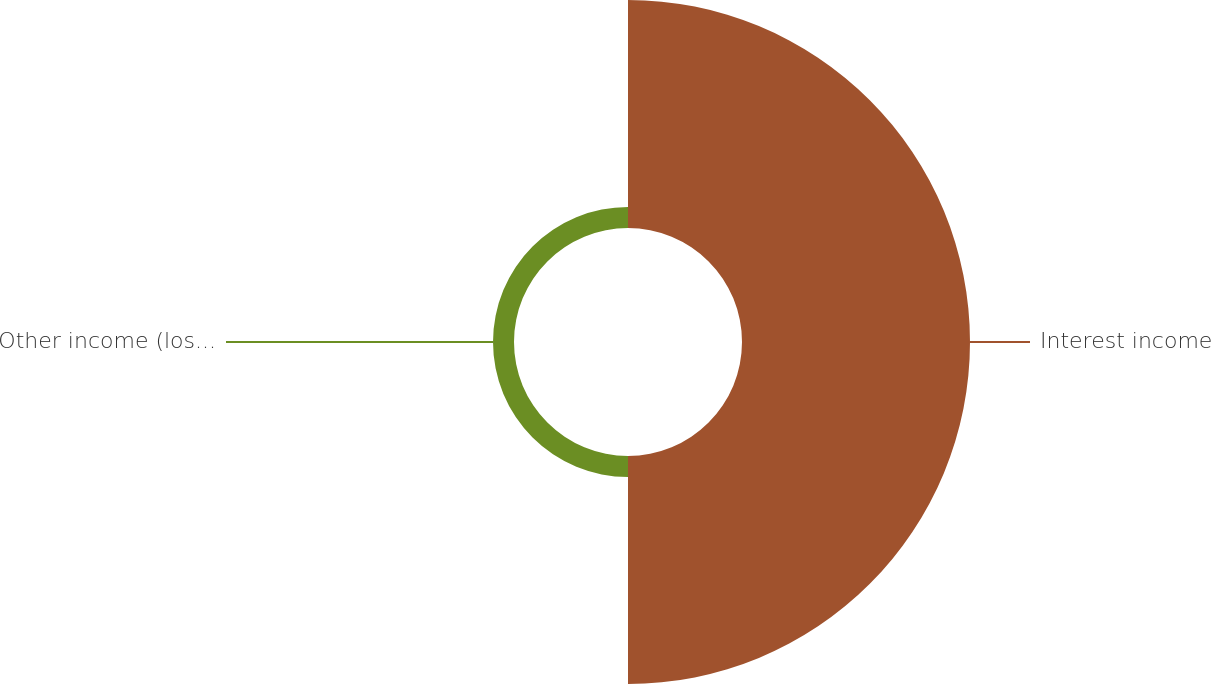Convert chart. <chart><loc_0><loc_0><loc_500><loc_500><pie_chart><fcel>Interest income<fcel>Other income (loss) net<nl><fcel>91.57%<fcel>8.43%<nl></chart> 